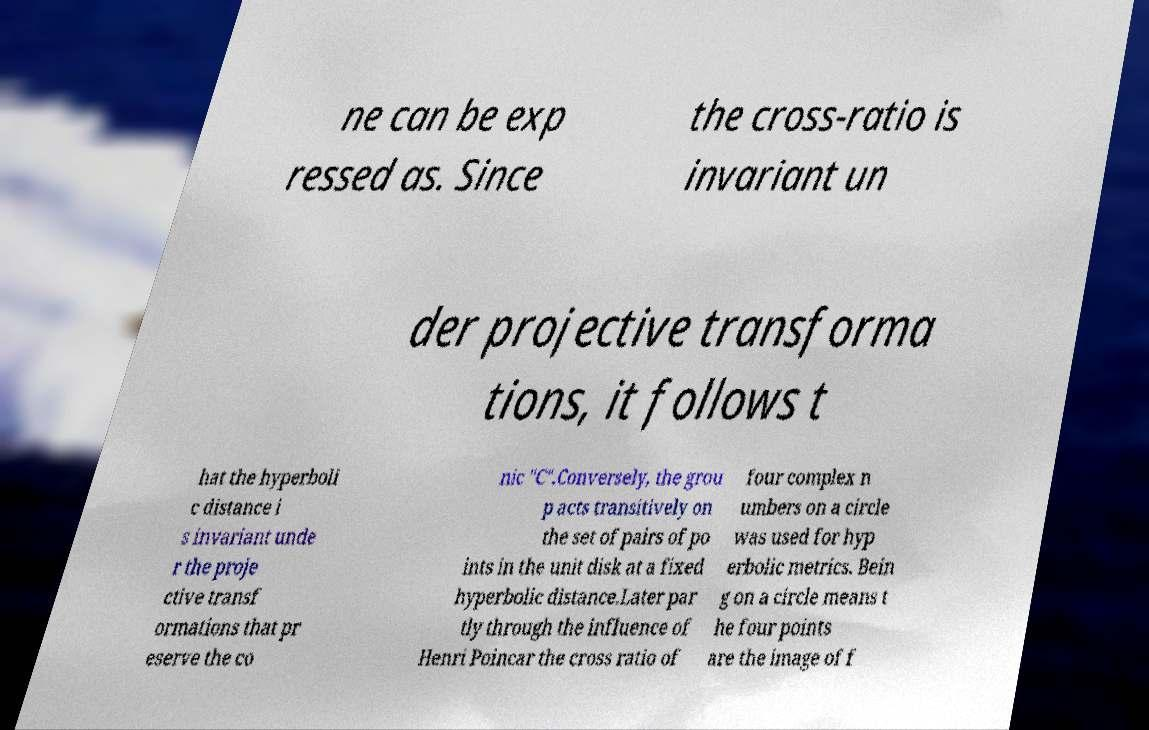Could you extract and type out the text from this image? ne can be exp ressed as. Since the cross-ratio is invariant un der projective transforma tions, it follows t hat the hyperboli c distance i s invariant unde r the proje ctive transf ormations that pr eserve the co nic "C".Conversely, the grou p acts transitively on the set of pairs of po ints in the unit disk at a fixed hyperbolic distance.Later par tly through the influence of Henri Poincar the cross ratio of four complex n umbers on a circle was used for hyp erbolic metrics. Bein g on a circle means t he four points are the image of f 